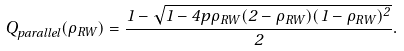<formula> <loc_0><loc_0><loc_500><loc_500>Q _ { p a r a l l e l } ( \rho _ { R W } ) = \frac { 1 - \sqrt { 1 - 4 p \rho _ { R W } ( 2 - \rho _ { R W } ) ( 1 - \rho _ { R W } ) ^ { 2 } } } { 2 } .</formula> 